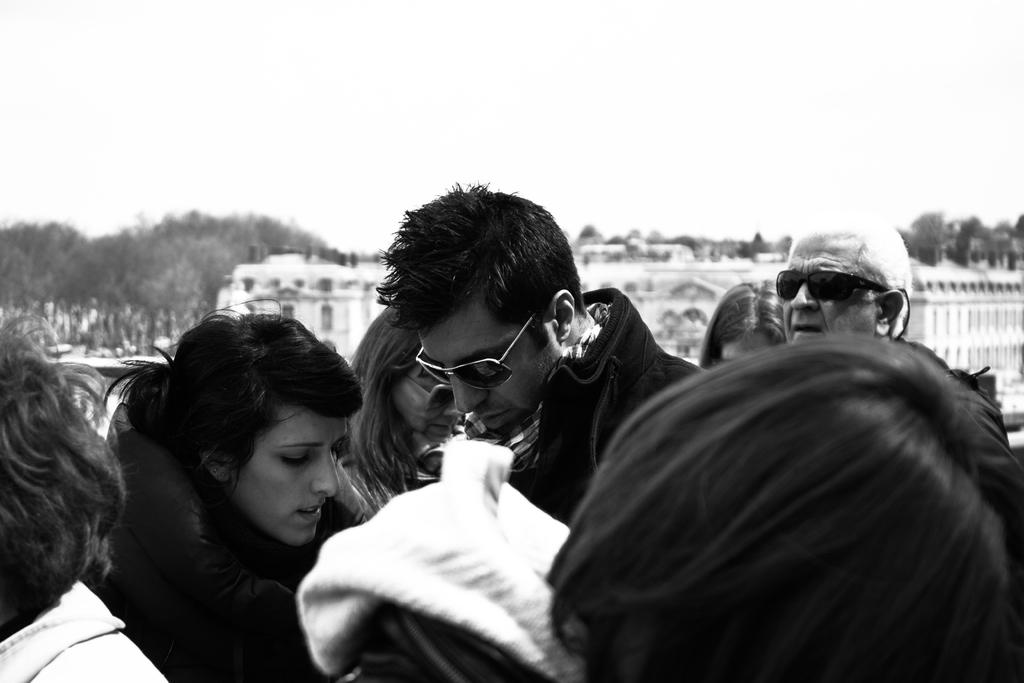What is located in the foreground of the image? There are people in the foreground of the image. What is the color scheme of the image? The image is black and white. What can be seen in the background of the image? There are buildings, trees, and the sky visible in the background of the image. What type of government is depicted in the image? There is no indication of a government in the image; it features people, buildings, trees, and the sky. Can you see any steam coming from the buildings in the image? There is no steam visible in the image; it is a black and white image of people, buildings, trees, and the sky. 